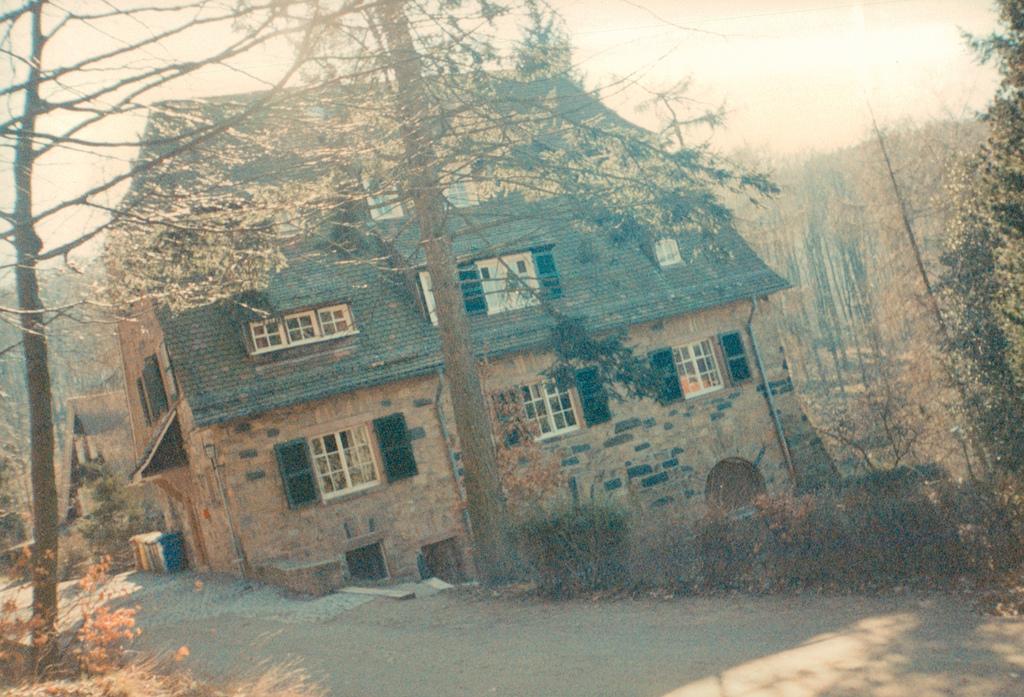In one or two sentences, can you explain what this image depicts? This is an outside view. At the bottom there is a road. Beside the road there are many plants and a building. In the background there are many trees. At the top of the image I can see the sky. 